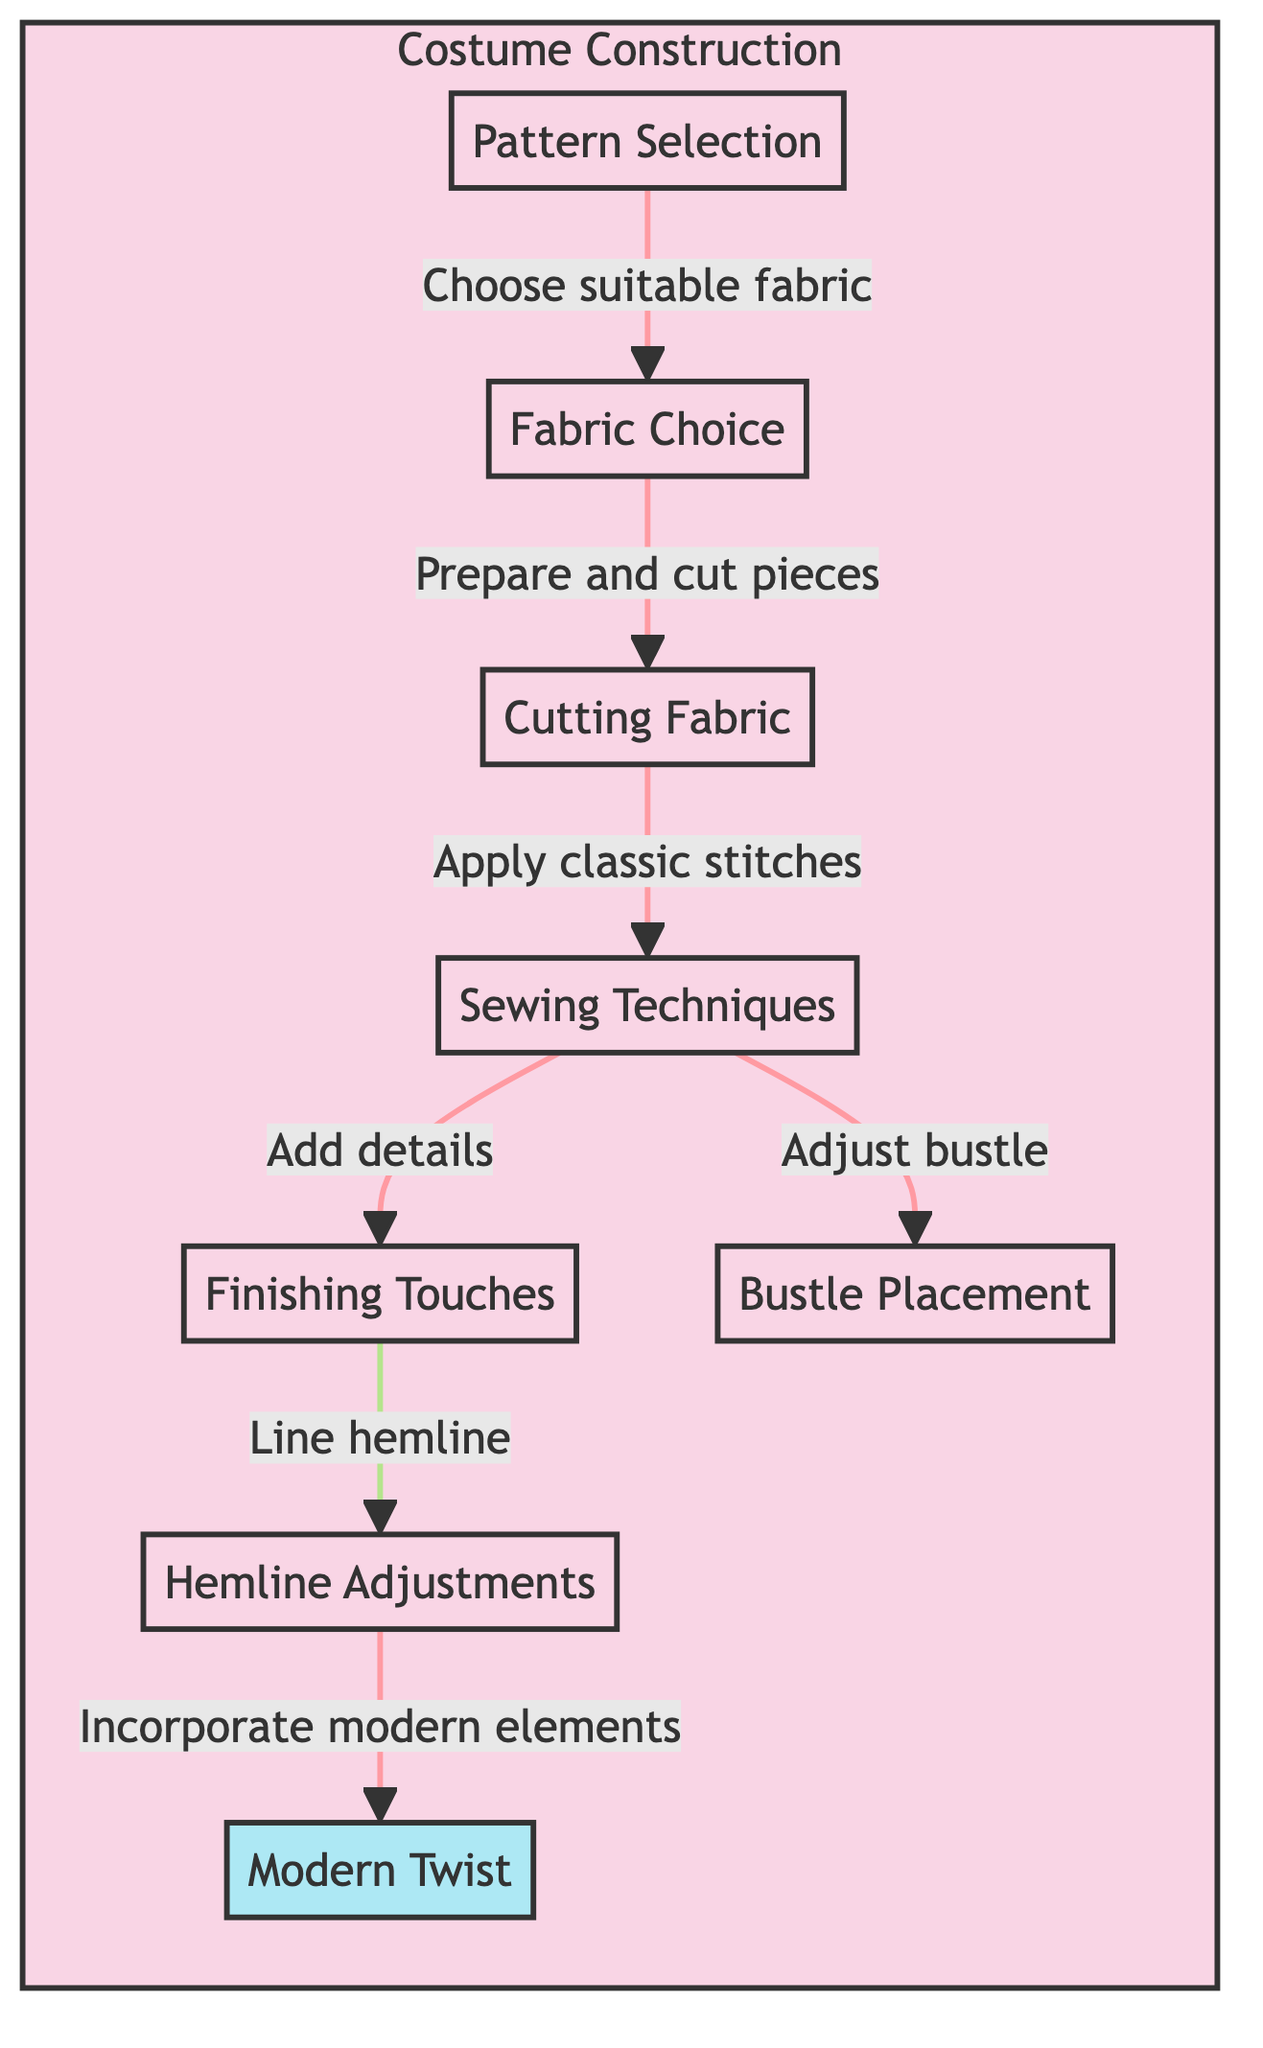What is the first step in the costume construction process? The first step in the diagram is "Pattern Selection," which is the initiating node of the flowchart, indicating the starting point of the process.
Answer: Pattern Selection How many nodes are in the diagram? By counting all the elements present in the diagram, I find a total of eight distinct nodes related to the costume construction process.
Answer: 8 What does the "Sewing Techniques" step lead to? The "Sewing Techniques" node has two outgoing paths that lead to "Finishing Touches" and "Bustle Placement," indicating what follows after applying sewing techniques.
Answer: Finishing Touches and Bustle Placement Which step involves adding modern elements? The "Incorporate modern elements" step is associated with "Hemline Adjustments," which is positioned as the final processing step in the flowchart.
Answer: Incorporate modern elements What is the relationship between "Fabric Choice" and "Cutting Fabric"? The relationship is direct and sequential, demonstrated by the arrow showing that after the "Fabric Choice," the next logical step is "Cutting Fabric."
Answer: Sequential relationship Which step incorporates a modern twist? The "Modern Twist" step is explicitly labeled and occurs after "Hemline Adjustments," specifying where contemporary influences are added to the historical patterns.
Answer: Modern Twist What is the last step before incorporating modern elements? The last step before putting modern elements into the costume is "Hemline Adjustments," which prepares the piece for the final modifications.
Answer: Hemline Adjustments What two steps follow "Sewing Techniques"? The two subsequent steps after "Sewing Techniques" are "Finishing Touches" and "Bustle Placement," indicating the potential paths to follow after sewing.
Answer: Finishing Touches and Bustle Placement 